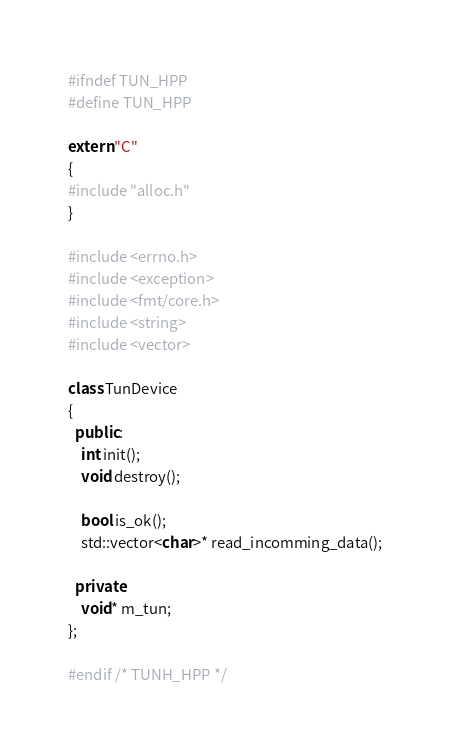<code> <loc_0><loc_0><loc_500><loc_500><_C++_>#ifndef TUN_HPP
#define TUN_HPP

extern "C"
{
#include "alloc.h"
}

#include <errno.h>
#include <exception>
#include <fmt/core.h>
#include <string>
#include <vector>

class TunDevice
{
  public:
	int init();
	void destroy();

	bool is_ok();
	std::vector<char>* read_incomming_data();

  private:
	void* m_tun;
};

#endif /* TUNH_HPP */
</code> 